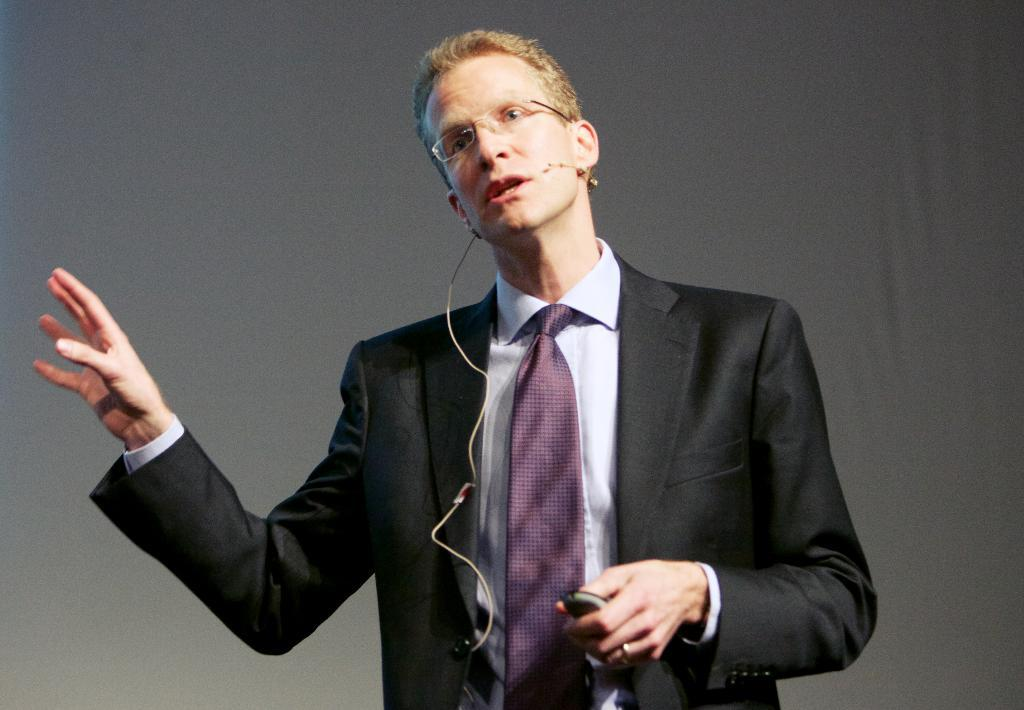Who is present in the image? There is a man in the image. What is the man wearing on his face? The man is wearing glasses (specs) in the image. What is the man holding in his hand? The man is holding a microphone in his hand. What can be seen behind the man in the image? There is a wall in the background of the image. What type of scarf is the man wearing in the image? The man is not wearing a scarf in the image. How many cows are visible in the image? There are no cows present in the image. 